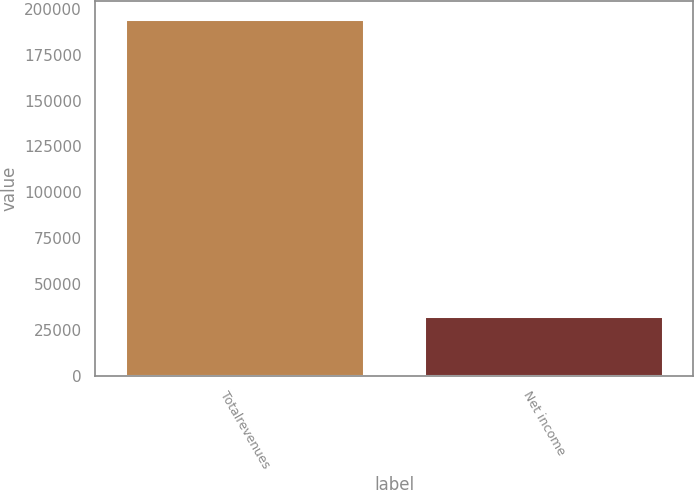Convert chart to OTSL. <chart><loc_0><loc_0><loc_500><loc_500><bar_chart><fcel>Totalrevenues<fcel>Net income<nl><fcel>194578<fcel>32686<nl></chart> 